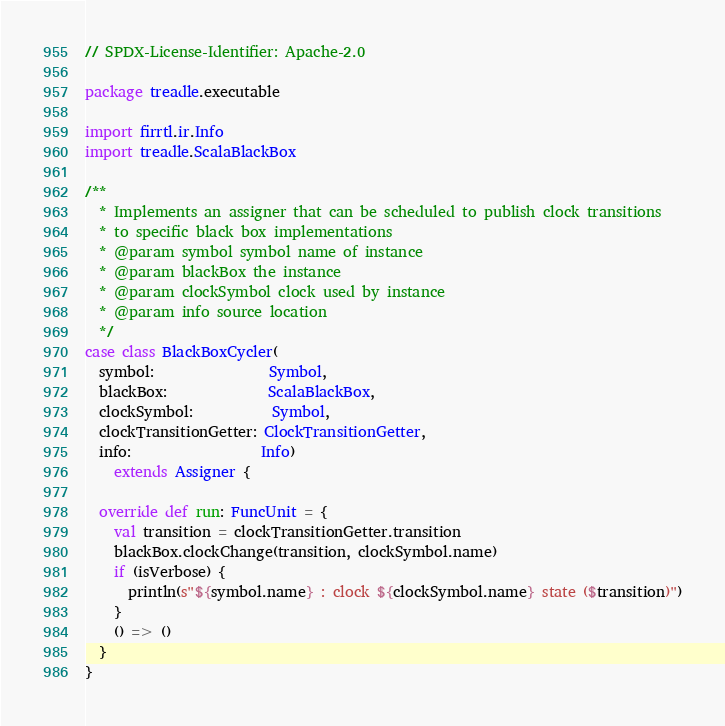<code> <loc_0><loc_0><loc_500><loc_500><_Scala_>// SPDX-License-Identifier: Apache-2.0

package treadle.executable

import firrtl.ir.Info
import treadle.ScalaBlackBox

/**
  * Implements an assigner that can be scheduled to publish clock transitions
  * to specific black box implementations
  * @param symbol symbol name of instance
  * @param blackBox the instance
  * @param clockSymbol clock used by instance
  * @param info source location
  */
case class BlackBoxCycler(
  symbol:                Symbol,
  blackBox:              ScalaBlackBox,
  clockSymbol:           Symbol,
  clockTransitionGetter: ClockTransitionGetter,
  info:                  Info)
    extends Assigner {

  override def run: FuncUnit = {
    val transition = clockTransitionGetter.transition
    blackBox.clockChange(transition, clockSymbol.name)
    if (isVerbose) {
      println(s"${symbol.name} : clock ${clockSymbol.name} state ($transition)")
    }
    () => ()
  }
}
</code> 